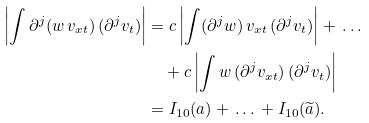Convert formula to latex. <formula><loc_0><loc_0><loc_500><loc_500>\left | \int \partial ^ { j } ( w \, v _ { x t } ) \, ( \partial ^ { j } v _ { t } ) \right | & = c \left | \int ( \partial ^ { j } w ) \, v _ { x t } \, ( \partial ^ { j } v _ { t } ) \right | + \, \dots \\ & \quad + c \left | \int w \, ( \partial ^ { j } v _ { x t } ) \, ( \partial ^ { j } v _ { t } ) \right | \\ & = I _ { 1 0 } ( a ) + \, \dots \, + I _ { 1 0 } ( \widetilde { a } ) .</formula> 